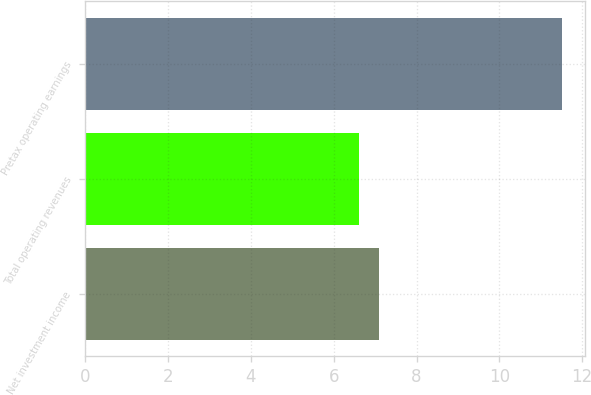<chart> <loc_0><loc_0><loc_500><loc_500><bar_chart><fcel>Net investment income<fcel>Total operating revenues<fcel>Pretax operating earnings<nl><fcel>7.09<fcel>6.6<fcel>11.5<nl></chart> 